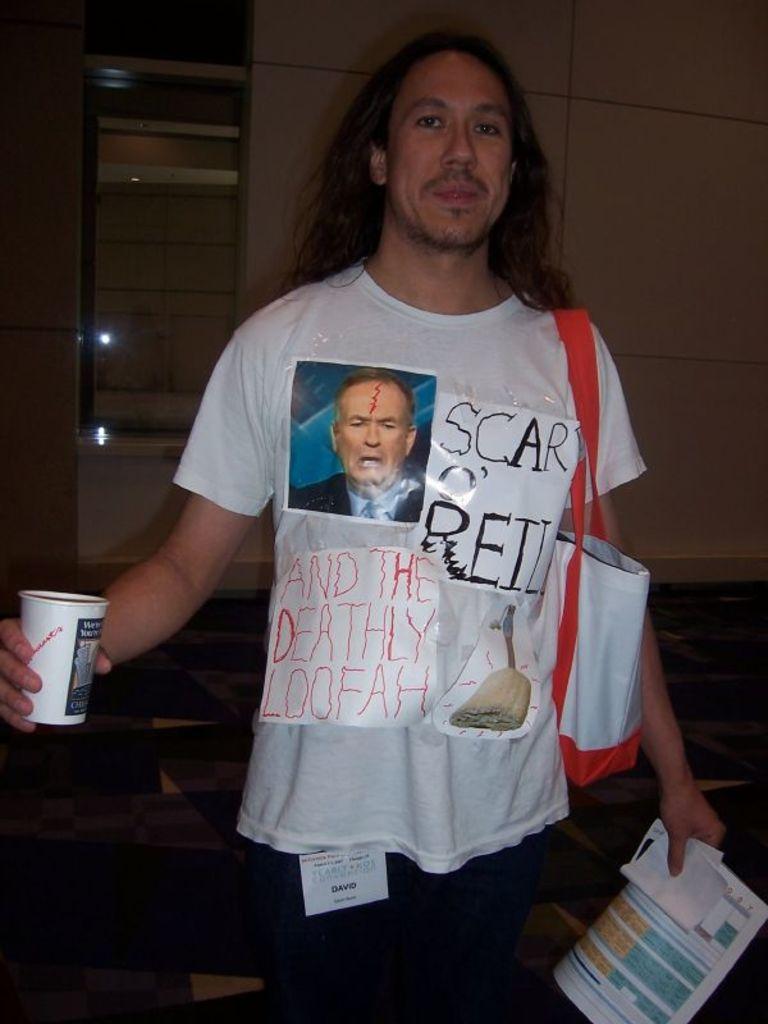What is on this man's shirt?
Your answer should be very brief. Scar o'reilly and the deathly loofah. 